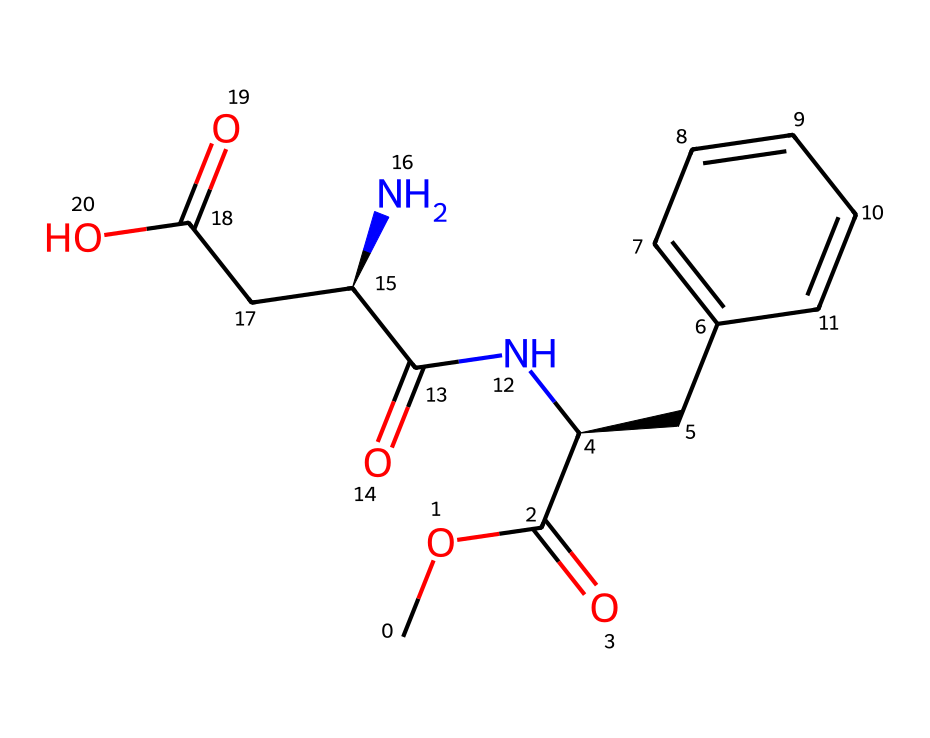What is the molecular formula of aspartame? The SMILES representation indicates the presence of carbon (C), hydrogen (H), nitrogen (N), and oxygen (O) atoms. Counting the atoms gives us a molecular formula of C14H18N2O5.
Answer: C14H18N2O5 How many chiral centers are present in aspartame? In the SMILES, there are two stereochemical indicators ([C@H]) suggesting two chiral centers. Each chiral center corresponds to a carbon atom that is connected to four different groups.
Answer: 2 What is the functional group present in aspartame that contains nitrogen? Analyzing the structure, the presence of a carbon atom (C) bonded to a nitrogen atom (N) in a carbonyl context indicates that the functional group is an amide (since there is an NH group adjacent to a carbonyl).
Answer: amide Which part of aspartame contributes to its sweetness? The presence of the phenyl group (the benzene ring) attached to the carbon chain is known to enhance the sweetness of the compound. The aromatic ring affects taste perceptions considerably.
Answer: phenyl group How does the chiral nature of aspartame affect its sweetness? Chiral compounds have non-superimposable mirror images. In the case of aspartame, only one enantiomer has the sweet taste due to its specific 3D arrangement that interacts with taste receptors, while the other may not.
Answer: only one enantiomer What is the role of the carboxylic acid functional group in aspartame? The carboxylic acid group (-COOH) contributes to solubility in water and influences the overall polarity of the molecule, which is important for its use in beverages.
Answer: solubility in water What makes aspartame a suitable sweetener for diet sodas? Its low-calorie nature, along with its intense sweetness (having a sweetness index much higher than sugar), allows it to provide sweetness without significant caloric intake.
Answer: low-calorie nature 